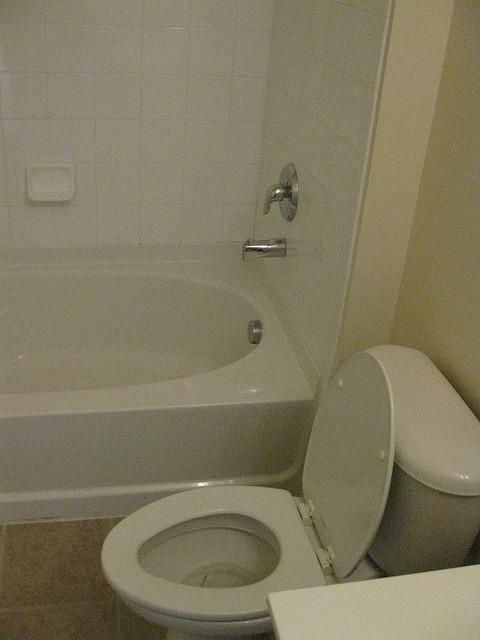How many toilets are in the photo?
Give a very brief answer. 1. 